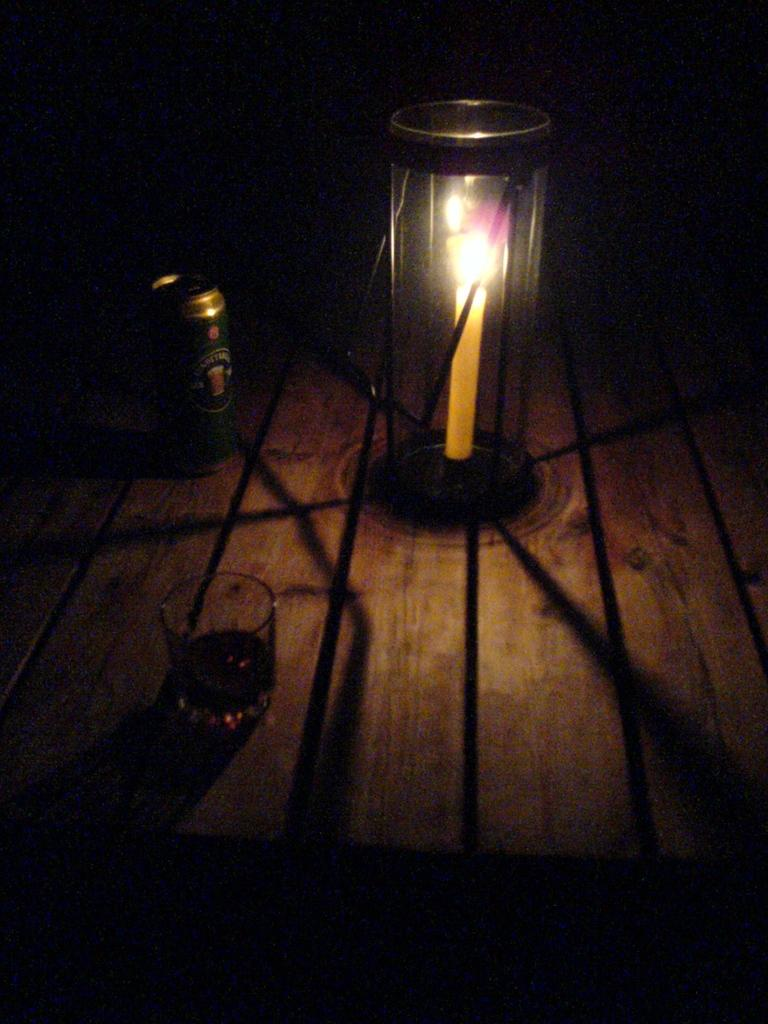What type of furniture is present in the image? There is a table in the image. What objects are on the table? There is a tin, a glass, and a candle placed in a holder on the table. How many people are present in the image? There is no person present in the image; it only shows a table with objects on it. 